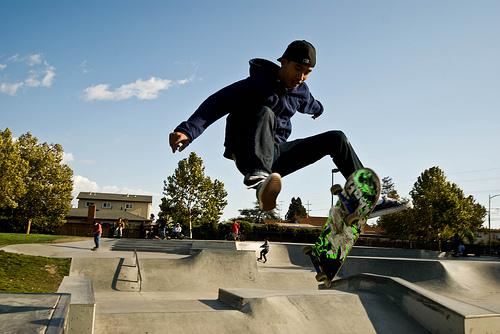Question: what are the people riding?
Choices:
A. Bikes.
B. Skateboards.
C. Motorcycles.
D. Horses.
Answer with the letter. Answer: B Question: why is the man in the air?
Choices:
A. He's ski jumping.
B. He's riding a bike.
C. He's doing a skateboard trick.
D. He's diving.
Answer with the letter. Answer: C Question: who is in the air?
Choices:
A. Pilot.
B. Balloonists.
C. A skateboarder.
D. Acrobat.
Answer with the letter. Answer: C Question: what is on the man's head?
Choices:
A. A hat.
B. Kerchief.
C. Hair.
D. Visor.
Answer with the letter. Answer: A Question: what color is the sky?
Choices:
A. Yellow.
B. Blue.
C. White.
D. Grey.
Answer with the letter. Answer: B 